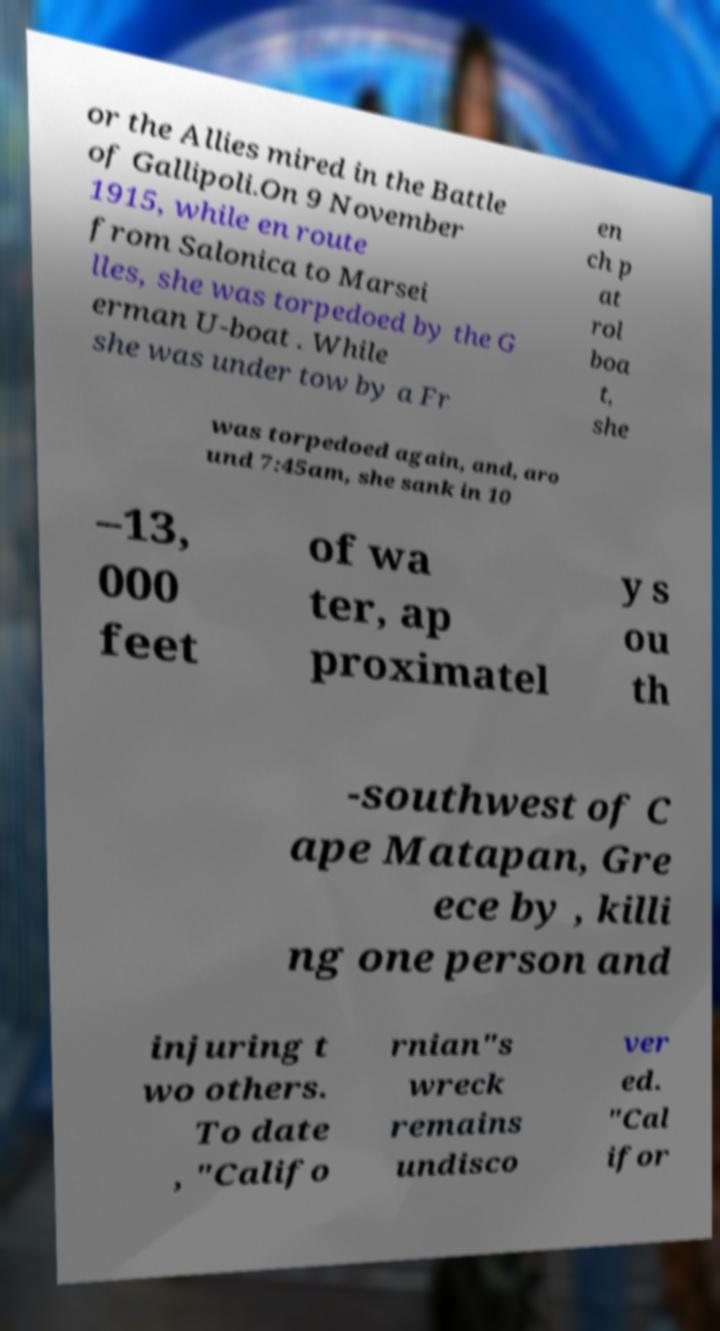Can you accurately transcribe the text from the provided image for me? or the Allies mired in the Battle of Gallipoli.On 9 November 1915, while en route from Salonica to Marsei lles, she was torpedoed by the G erman U-boat . While she was under tow by a Fr en ch p at rol boa t, she was torpedoed again, and, aro und 7:45am, she sank in 10 –13, 000 feet of wa ter, ap proximatel y s ou th -southwest of C ape Matapan, Gre ece by , killi ng one person and injuring t wo others. To date , "Califo rnian"s wreck remains undisco ver ed. "Cal ifor 